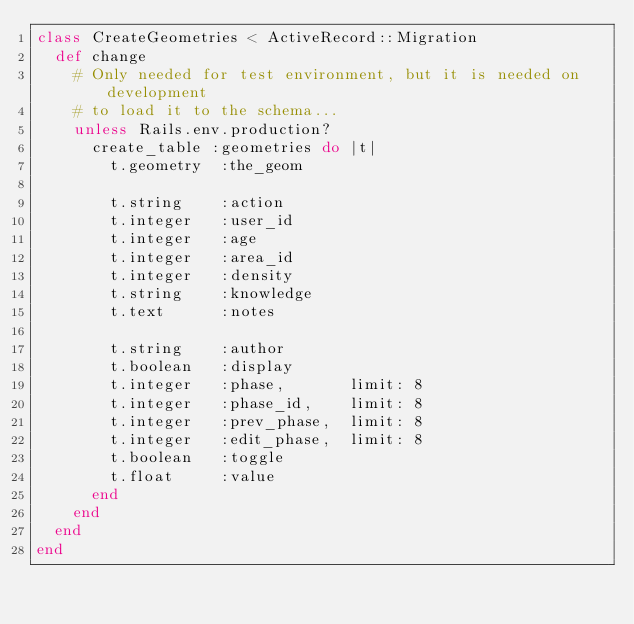<code> <loc_0><loc_0><loc_500><loc_500><_Ruby_>class CreateGeometries < ActiveRecord::Migration
  def change
    # Only needed for test environment, but it is needed on development
    # to load it to the schema...
    unless Rails.env.production?
      create_table :geometries do |t|
        t.geometry  :the_geom

        t.string    :action
        t.integer   :user_id
        t.integer   :age
        t.integer   :area_id
        t.integer   :density
        t.string    :knowledge
        t.text      :notes

        t.string    :author
        t.boolean   :display
        t.integer   :phase,       limit: 8
        t.integer   :phase_id,    limit: 8
        t.integer   :prev_phase,  limit: 8
        t.integer   :edit_phase,  limit: 8
        t.boolean   :toggle
        t.float     :value
      end
    end
  end
end
</code> 